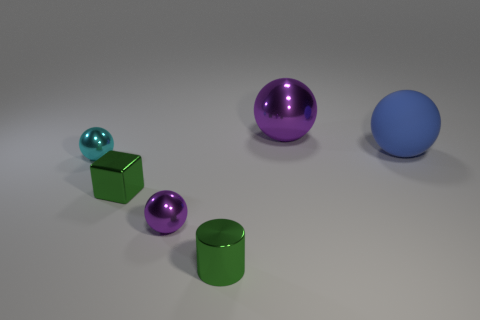Subtract all shiny spheres. How many spheres are left? 1 Add 1 small green metallic cylinders. How many objects exist? 7 Subtract all blue spheres. How many spheres are left? 3 Subtract all blocks. How many objects are left? 5 Subtract 1 cylinders. How many cylinders are left? 0 Subtract all blue spheres. Subtract all brown cubes. How many spheres are left? 3 Subtract all yellow cylinders. How many gray balls are left? 0 Subtract all big blue rubber objects. Subtract all large blue matte balls. How many objects are left? 4 Add 6 large rubber things. How many large rubber things are left? 7 Add 3 large purple metallic objects. How many large purple metallic objects exist? 4 